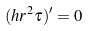Convert formula to latex. <formula><loc_0><loc_0><loc_500><loc_500>( h r ^ { 2 } \tau ) ^ { \prime } = 0</formula> 